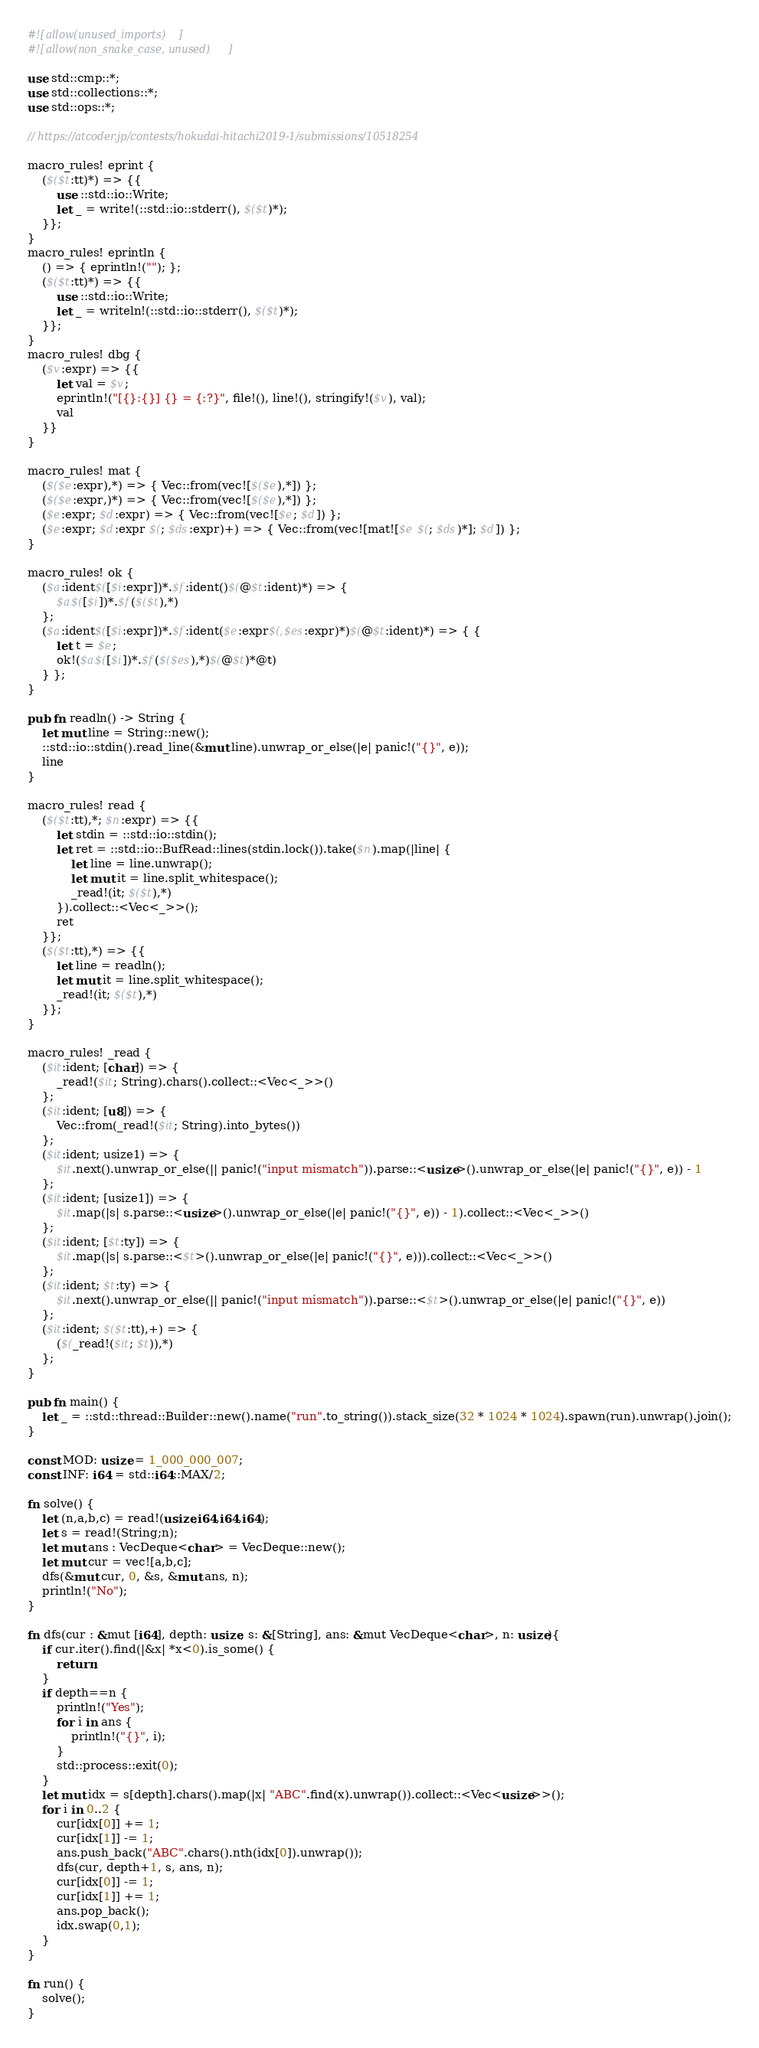<code> <loc_0><loc_0><loc_500><loc_500><_Rust_>#![allow(unused_imports)]
#![allow(non_snake_case, unused)]

use std::cmp::*;
use std::collections::*;
use std::ops::*;

// https://atcoder.jp/contests/hokudai-hitachi2019-1/submissions/10518254

macro_rules! eprint {
	($($t:tt)*) => {{
		use ::std::io::Write;
		let _ = write!(::std::io::stderr(), $($t)*);
	}};
}
macro_rules! eprintln {
	() => { eprintln!(""); };
	($($t:tt)*) => {{
		use ::std::io::Write;
		let _ = writeln!(::std::io::stderr(), $($t)*);
	}};
}
macro_rules! dbg {
	($v:expr) => {{
		let val = $v;
		eprintln!("[{}:{}] {} = {:?}", file!(), line!(), stringify!($v), val);
		val
	}}
}

macro_rules! mat {
	($($e:expr),*) => { Vec::from(vec![$($e),*]) };
	($($e:expr,)*) => { Vec::from(vec![$($e),*]) };
	($e:expr; $d:expr) => { Vec::from(vec![$e; $d]) };
	($e:expr; $d:expr $(; $ds:expr)+) => { Vec::from(vec![mat![$e $(; $ds)*]; $d]) };
}

macro_rules! ok {
	($a:ident$([$i:expr])*.$f:ident()$(@$t:ident)*) => {
		$a$([$i])*.$f($($t),*)
	};
	($a:ident$([$i:expr])*.$f:ident($e:expr$(,$es:expr)*)$(@$t:ident)*) => { {
		let t = $e;
		ok!($a$([$i])*.$f($($es),*)$(@$t)*@t)
	} };
}

pub fn readln() -> String {
	let mut line = String::new();
	::std::io::stdin().read_line(&mut line).unwrap_or_else(|e| panic!("{}", e));
	line
}

macro_rules! read {
	($($t:tt),*; $n:expr) => {{
		let stdin = ::std::io::stdin();
		let ret = ::std::io::BufRead::lines(stdin.lock()).take($n).map(|line| {
			let line = line.unwrap();
			let mut it = line.split_whitespace();
			_read!(it; $($t),*)
		}).collect::<Vec<_>>();
		ret
	}};
	($($t:tt),*) => {{
		let line = readln();
		let mut it = line.split_whitespace();
		_read!(it; $($t),*)
	}};
}

macro_rules! _read {
	($it:ident; [char]) => {
		_read!($it; String).chars().collect::<Vec<_>>()
	};
	($it:ident; [u8]) => {
		Vec::from(_read!($it; String).into_bytes())
	};
	($it:ident; usize1) => {
		$it.next().unwrap_or_else(|| panic!("input mismatch")).parse::<usize>().unwrap_or_else(|e| panic!("{}", e)) - 1
	};
	($it:ident; [usize1]) => {
		$it.map(|s| s.parse::<usize>().unwrap_or_else(|e| panic!("{}", e)) - 1).collect::<Vec<_>>()
	};
	($it:ident; [$t:ty]) => {
		$it.map(|s| s.parse::<$t>().unwrap_or_else(|e| panic!("{}", e))).collect::<Vec<_>>()
	};
	($it:ident; $t:ty) => {
		$it.next().unwrap_or_else(|| panic!("input mismatch")).parse::<$t>().unwrap_or_else(|e| panic!("{}", e))
	};
	($it:ident; $($t:tt),+) => {
		($(_read!($it; $t)),*)
	};
}

pub fn main() {
	let _ = ::std::thread::Builder::new().name("run".to_string()).stack_size(32 * 1024 * 1024).spawn(run).unwrap().join();
}

const MOD: usize = 1_000_000_007;
const INF: i64 = std::i64::MAX/2;

fn solve() {
    let (n,a,b,c) = read!(usize,i64,i64,i64);
    let s = read!(String;n);
    let mut ans : VecDeque<char> = VecDeque::new();
    let mut cur = vec![a,b,c];
    dfs(&mut cur, 0, &s, &mut ans, n);
    println!("No");
}

fn dfs(cur : &mut [i64], depth: usize, s: &[String], ans: &mut VecDeque<char>, n: usize){
    if cur.iter().find(|&x| *x<0).is_some() {
        return;
    }
    if depth==n {
        println!("Yes");
        for i in ans {
            println!("{}", i);
        }
        std::process::exit(0);
    }
    let mut idx = s[depth].chars().map(|x| "ABC".find(x).unwrap()).collect::<Vec<usize>>();
    for i in 0..2 {
        cur[idx[0]] += 1;
        cur[idx[1]] -= 1;
        ans.push_back("ABC".chars().nth(idx[0]).unwrap());
        dfs(cur, depth+1, s, ans, n);
        cur[idx[0]] -= 1;
        cur[idx[1]] += 1;
        ans.pop_back();
        idx.swap(0,1);
    }
}

fn run() {
    solve();
}
</code> 